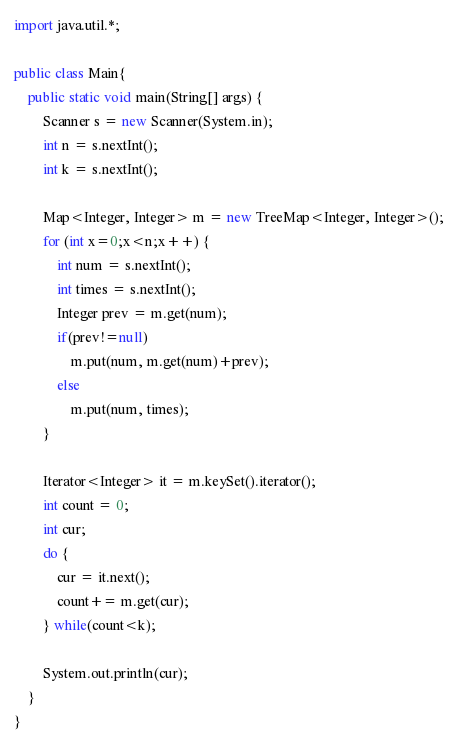Convert code to text. <code><loc_0><loc_0><loc_500><loc_500><_Java_>import java.util.*;

public class Main{
	public static void main(String[] args) {
		Scanner s = new Scanner(System.in);
		int n = s.nextInt();
		int k = s.nextInt();
		
		Map<Integer, Integer> m = new TreeMap<Integer, Integer>();
		for (int x=0;x<n;x++) {
			int num = s.nextInt();
			int times = s.nextInt();
			Integer prev = m.get(num);
			if(prev!=null)
				m.put(num, m.get(num)+prev);
			else
				m.put(num, times);
		}
		
		Iterator<Integer> it = m.keySet().iterator();
		int count = 0;
		int cur;
		do {
			cur = it.next();
			count+= m.get(cur);
		} while(count<k);
		
		System.out.println(cur);
	}
}</code> 